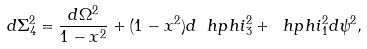Convert formula to latex. <formula><loc_0><loc_0><loc_500><loc_500>d \Sigma _ { 4 } ^ { 2 } = \frac { d \Omega ^ { 2 } } { 1 - x ^ { 2 } } + ( 1 - x ^ { 2 } ) d \ h p h i _ { 3 } ^ { 2 } + \ h p h i _ { 1 } ^ { 2 } d \psi ^ { 2 } ,</formula> 